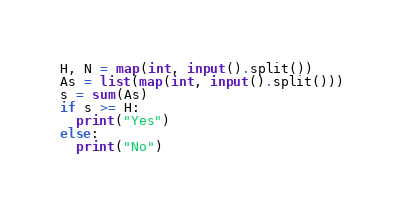Convert code to text. <code><loc_0><loc_0><loc_500><loc_500><_Python_>H, N = map(int, input().split())
As = list(map(int, input().split()))
s = sum(As)
if s >= H:
  print("Yes")
else:
  print("No")
</code> 